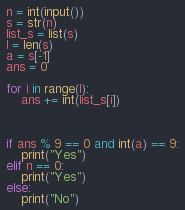<code> <loc_0><loc_0><loc_500><loc_500><_Python_>n = int(input())
s = str(n)
list_s = list(s)
l = len(s)
a = s[-1]
ans = 0

for i in range(l):
    ans += int(list_s[i])



if ans % 9 == 0 and int(a) == 9:
    print("Yes")
elif n == 0:
    print("Yes")
else:
    print("No")</code> 